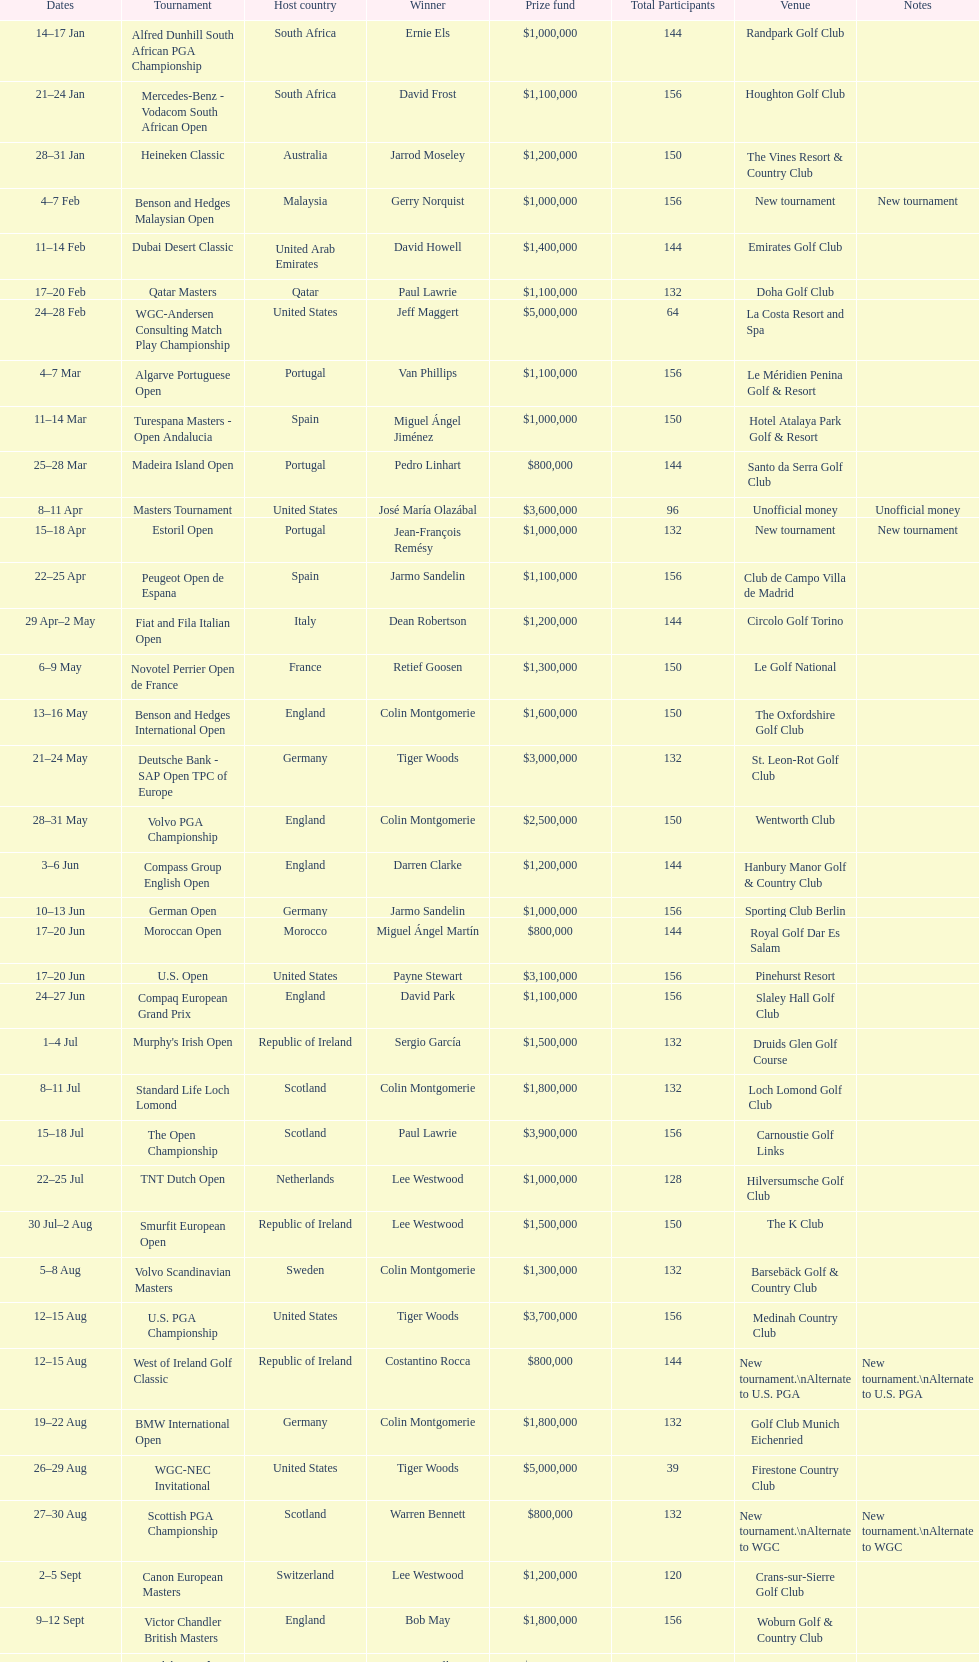Which tournament was later, volvo pga or algarve portuguese open? Volvo PGA. 